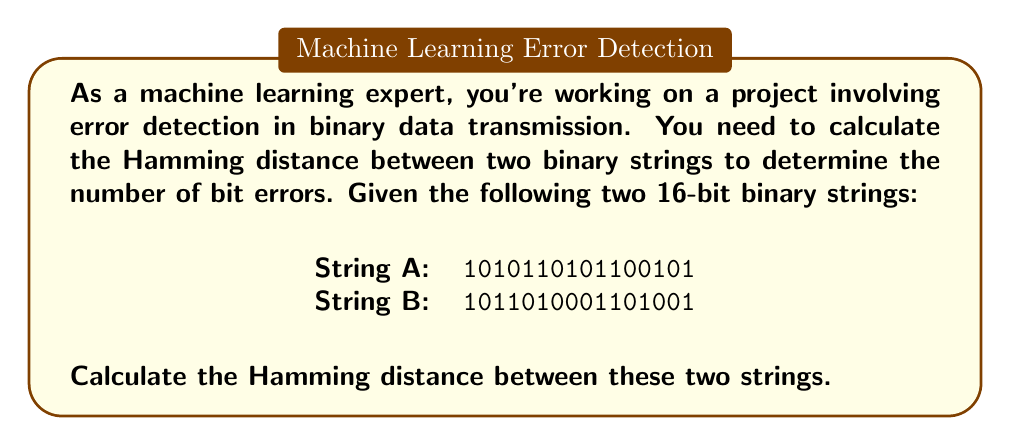What is the answer to this math problem? To calculate the Hamming distance between two binary strings, we need to compare the bits at each position and count the number of positions where the bits differ. Here's a step-by-step explanation:

1. Align the two binary strings:
   A: 1010110101100101
   B: 1011010001101001

2. Compare each bit position:
   A: 1010110101100101
   B: 1011010001101001
      ^ ^    ^^   ^

3. Count the differences:
   - Position 2: A has 0, B has 1
   - Position 4: A has 0, B has 1
   - Position 7: A has 1, B has 0
   - Position 8: A has 0, B has 1
   - Position 13: A has 0, B has 1

4. Sum up the total number of differences:

   $$ \text{Hamming distance} = \sum_{i=1}^{n} (A_i \oplus B_i) $$

   Where $\oplus$ represents the XOR operation, and $n$ is the length of the binary strings.

In this case, we have 5 positions where the bits differ.

The Hamming distance is particularly useful in machine learning applications involving error detection and correction, such as in communication systems or data storage. It provides a measure of the minimum number of bit flips required to transform one binary string into another.
Answer: The Hamming distance between the two binary strings is 5. 